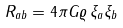Convert formula to latex. <formula><loc_0><loc_0><loc_500><loc_500>R _ { a b } = 4 \pi G \varrho \, \xi _ { a } \xi _ { b }</formula> 